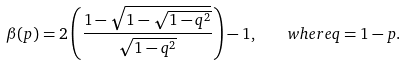<formula> <loc_0><loc_0><loc_500><loc_500>\beta ( p ) = 2 \left ( \frac { 1 - \sqrt { 1 - \sqrt { 1 - q ^ { 2 } } } } { \sqrt { 1 - q ^ { 2 } } } \right ) - 1 , \quad w h e r e q = 1 - p .</formula> 